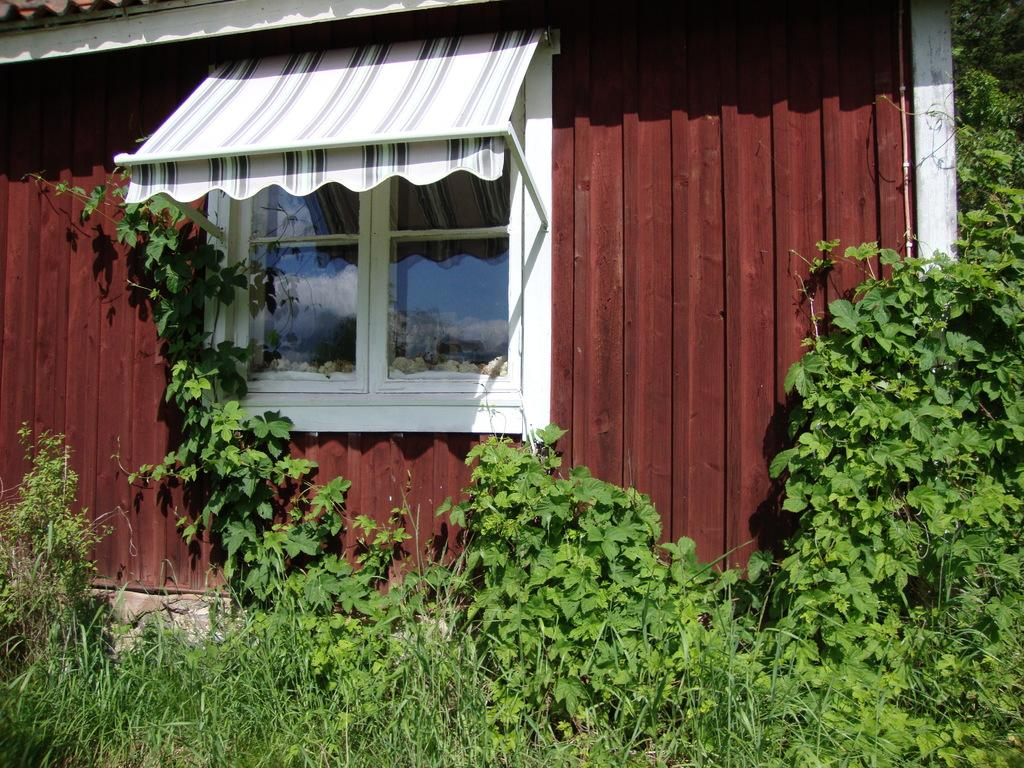What type of structure is present in the image? There is a building in the picture. What feature can be seen on the building? The building has a glass window. What type of natural environment is visible in the image? There is grass in the picture. What type of vegetation is present in the image? There are plants in the picture. How many slaves are depicted in the image? There are no slaves present in the image. What type of relationship do the sisters have in the image? There are no sisters present in the image. 